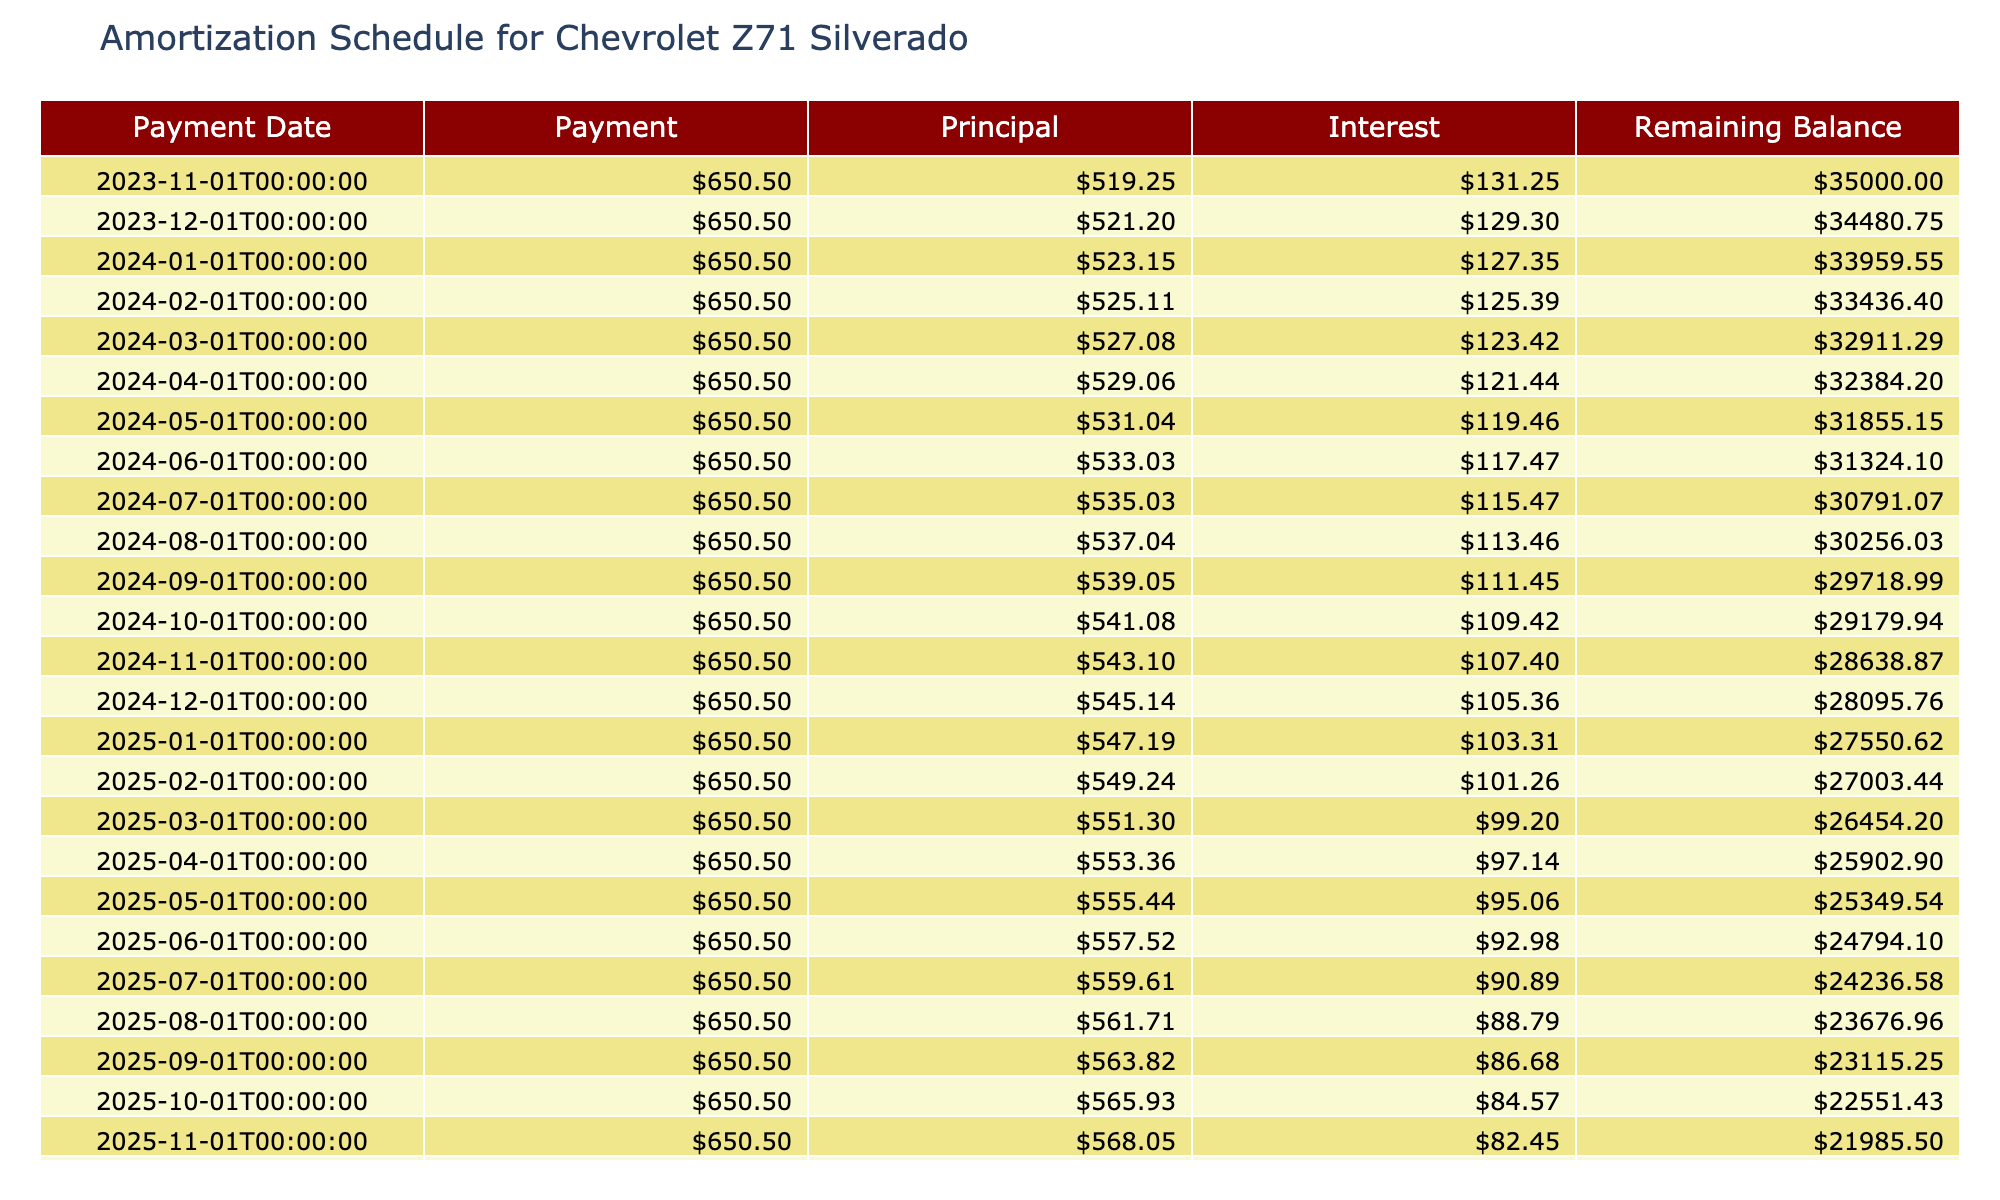What is the loan amount for the Chevrolet Z71 Silverado? The loan amount is specified directly in the table under the relevant column. It states 35000.
Answer: 35000 What is the total interest paid over the term of the car loan? The total interest paid is provided in the table under the Total Interest column, which indicates 3030.
Answer: 3030 How much is the monthly payment for the Chevrolet truck? The monthly payment is listed in the table, specifically under the Monthly Payment column, showing it as 650.50.
Answer: 650.50 What is the remaining balance after the first payment? The table indicates the remaining balance before the first payment is made, which is equal to the total loan amount of 35000.
Answer: 35000 How much total payment will be made at the end of the loan term? The total payment can be retrieved from the Total Payment column in the table, which shows 39030.
Answer: 39030 Is the first payment due on a weekend? To determine if the first payment date (2023-11-01) is a weekend, we check the day of the week for that date. It falls on a Wednesday, which is not a weekend.
Answer: No What percentage of the total payment is interest? To find the percentage of the total payment that is interest, we calculate (Total Interest / Total Payment) * 100, which is (3030 / 39030) * 100 = 7.76%.
Answer: 7.76% What is the total amount of principal paid after the first month? After the first month, to find the principal paid, we need to subtract the first month's interest from the monthly payment. The interest for the first month is 35000 * (0.045 / 12) = 131.25, so Principal = 650.50 - 131.25 = 519.25.
Answer: 519.25 If the loan term were extended by 12 months, how would the monthly payment change? If we extend the loan term, we must calculate the new total payment, which is the sum of the original total payment plus the additional interest that would accrue over the new 12 months. So the new total payment would be 39030 + 3030, and we would need to divide it by the new total term (72 months). The new monthly payment would be approximately 541.67.
Answer: 541.67 